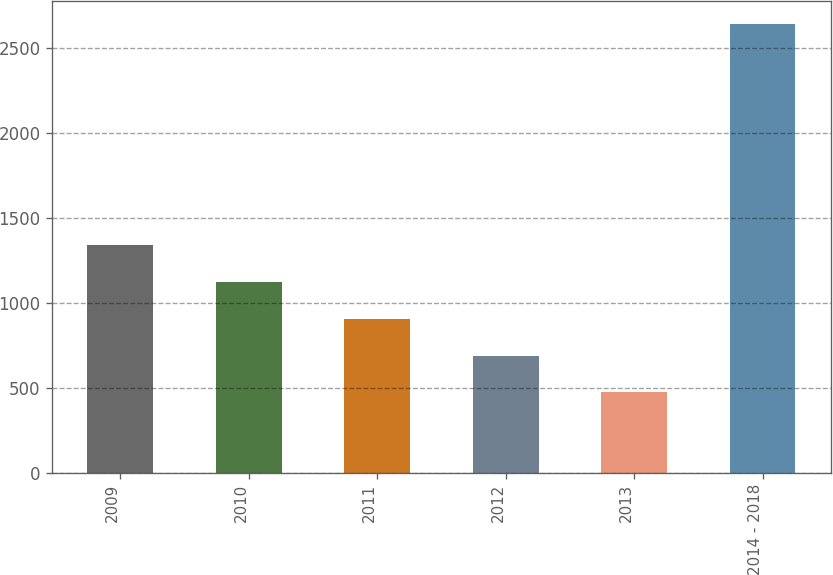Convert chart. <chart><loc_0><loc_0><loc_500><loc_500><bar_chart><fcel>2009<fcel>2010<fcel>2011<fcel>2012<fcel>2013<fcel>2014 - 2018<nl><fcel>1340.8<fcel>1123.6<fcel>906.4<fcel>689.2<fcel>472<fcel>2644<nl></chart> 